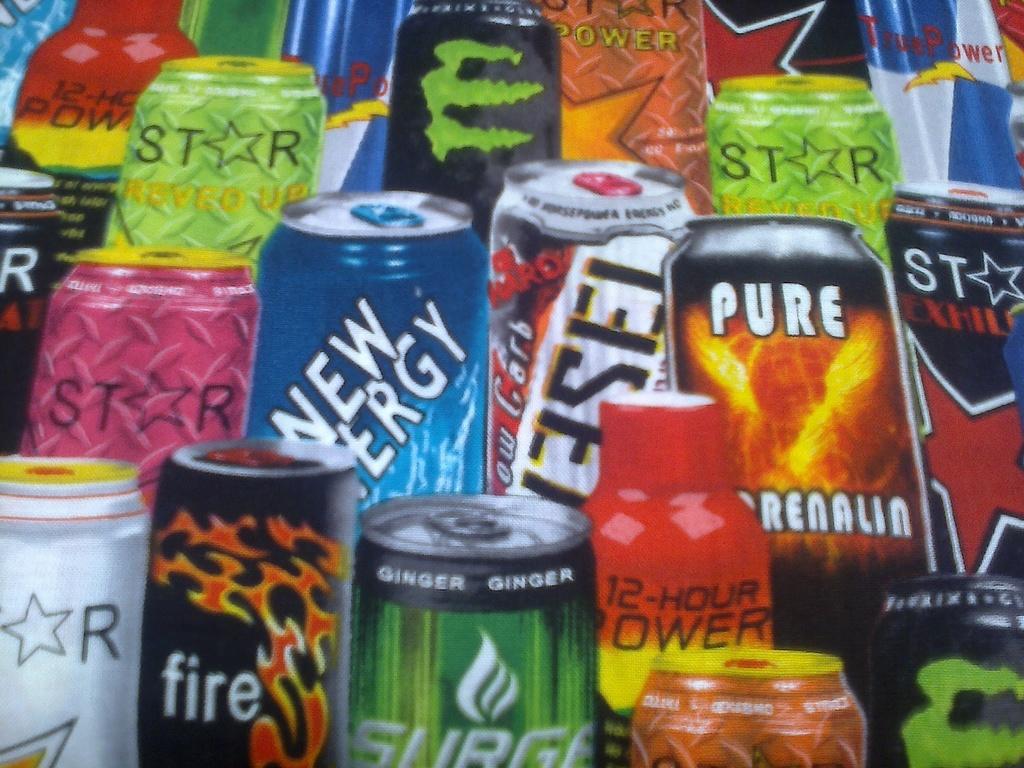What flavor is the surge drink?
Offer a very short reply. Ginger. 